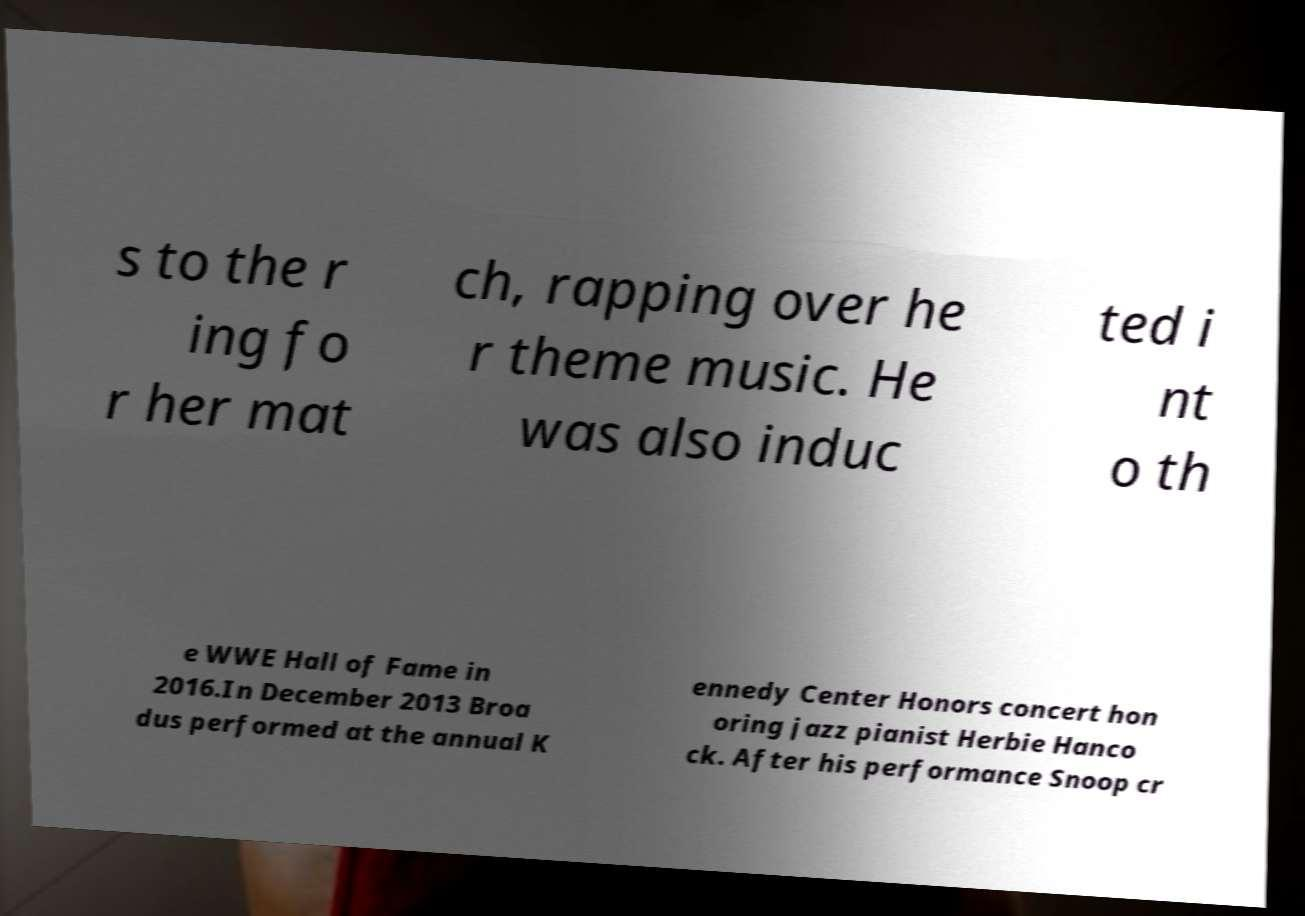There's text embedded in this image that I need extracted. Can you transcribe it verbatim? s to the r ing fo r her mat ch, rapping over he r theme music. He was also induc ted i nt o th e WWE Hall of Fame in 2016.In December 2013 Broa dus performed at the annual K ennedy Center Honors concert hon oring jazz pianist Herbie Hanco ck. After his performance Snoop cr 